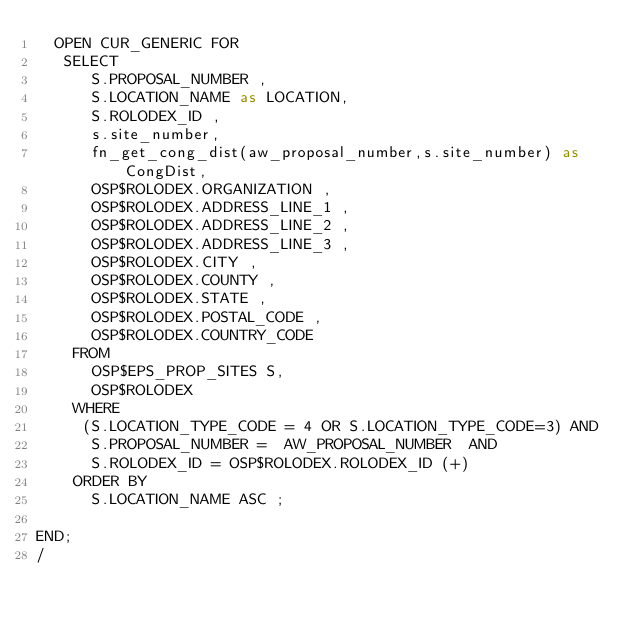Convert code to text. <code><loc_0><loc_0><loc_500><loc_500><_SQL_>  OPEN CUR_GENERIC FOR
   SELECT
      S.PROPOSAL_NUMBER ,
      S.LOCATION_NAME as LOCATION,
      S.ROLODEX_ID ,
	  s.site_number,
	  fn_get_cong_dist(aw_proposal_number,s.site_number) as CongDist,
      OSP$ROLODEX.ORGANIZATION ,
      OSP$ROLODEX.ADDRESS_LINE_1 ,
      OSP$ROLODEX.ADDRESS_LINE_2 ,
      OSP$ROLODEX.ADDRESS_LINE_3 ,
      OSP$ROLODEX.CITY ,
      OSP$ROLODEX.COUNTY ,
      OSP$ROLODEX.STATE ,
      OSP$ROLODEX.POSTAL_CODE ,
      OSP$ROLODEX.COUNTRY_CODE 
    FROM
      OSP$EPS_PROP_SITES S,
      OSP$ROLODEX
    WHERE
	 (S.LOCATION_TYPE_CODE = 4 OR S.LOCATION_TYPE_CODE=3) AND
      S.PROPOSAL_NUMBER =  AW_PROPOSAL_NUMBER  AND
      S.ROLODEX_ID = OSP$ROLODEX.ROLODEX_ID (+)
    ORDER BY
      S.LOCATION_NAME ASC ;

END;
/


</code> 